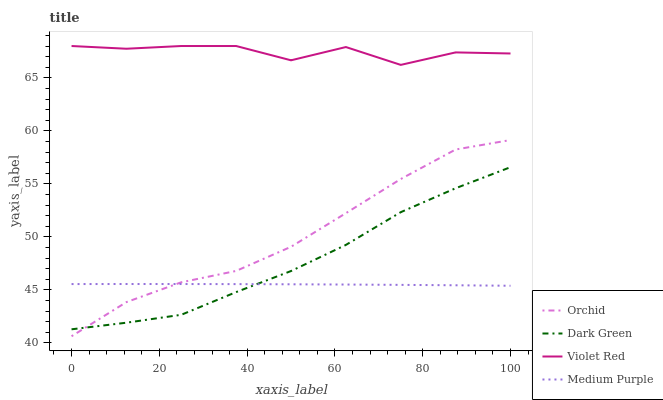Does Medium Purple have the minimum area under the curve?
Answer yes or no. Yes. Does Violet Red have the maximum area under the curve?
Answer yes or no. Yes. Does Dark Green have the minimum area under the curve?
Answer yes or no. No. Does Dark Green have the maximum area under the curve?
Answer yes or no. No. Is Medium Purple the smoothest?
Answer yes or no. Yes. Is Violet Red the roughest?
Answer yes or no. Yes. Is Dark Green the smoothest?
Answer yes or no. No. Is Dark Green the roughest?
Answer yes or no. No. Does Dark Green have the lowest value?
Answer yes or no. No. Does Dark Green have the highest value?
Answer yes or no. No. Is Medium Purple less than Violet Red?
Answer yes or no. Yes. Is Violet Red greater than Medium Purple?
Answer yes or no. Yes. Does Medium Purple intersect Violet Red?
Answer yes or no. No. 